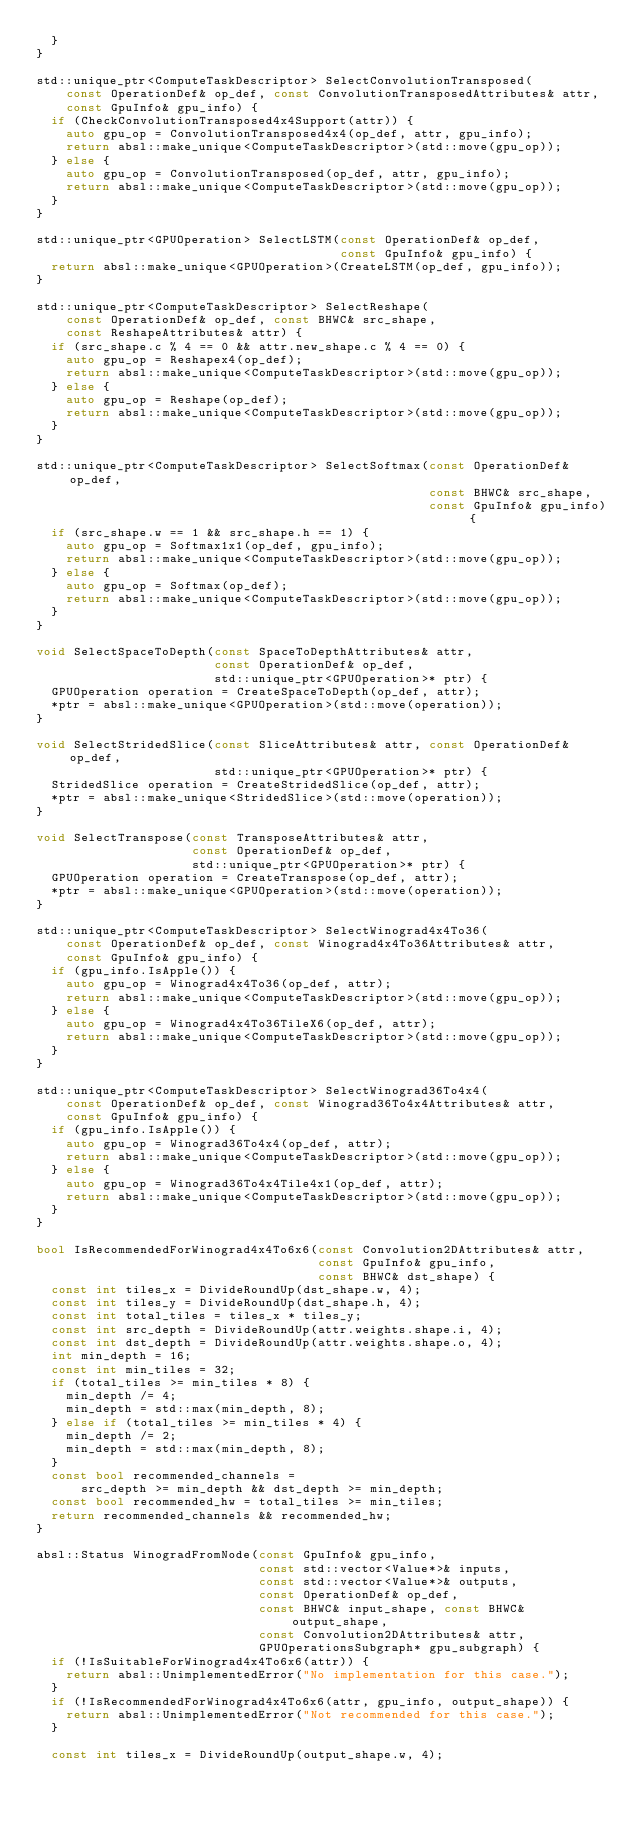<code> <loc_0><loc_0><loc_500><loc_500><_C++_>  }
}

std::unique_ptr<ComputeTaskDescriptor> SelectConvolutionTransposed(
    const OperationDef& op_def, const ConvolutionTransposedAttributes& attr,
    const GpuInfo& gpu_info) {
  if (CheckConvolutionTransposed4x4Support(attr)) {
    auto gpu_op = ConvolutionTransposed4x4(op_def, attr, gpu_info);
    return absl::make_unique<ComputeTaskDescriptor>(std::move(gpu_op));
  } else {
    auto gpu_op = ConvolutionTransposed(op_def, attr, gpu_info);
    return absl::make_unique<ComputeTaskDescriptor>(std::move(gpu_op));
  }
}

std::unique_ptr<GPUOperation> SelectLSTM(const OperationDef& op_def,
                                         const GpuInfo& gpu_info) {
  return absl::make_unique<GPUOperation>(CreateLSTM(op_def, gpu_info));
}

std::unique_ptr<ComputeTaskDescriptor> SelectReshape(
    const OperationDef& op_def, const BHWC& src_shape,
    const ReshapeAttributes& attr) {
  if (src_shape.c % 4 == 0 && attr.new_shape.c % 4 == 0) {
    auto gpu_op = Reshapex4(op_def);
    return absl::make_unique<ComputeTaskDescriptor>(std::move(gpu_op));
  } else {
    auto gpu_op = Reshape(op_def);
    return absl::make_unique<ComputeTaskDescriptor>(std::move(gpu_op));
  }
}

std::unique_ptr<ComputeTaskDescriptor> SelectSoftmax(const OperationDef& op_def,
                                                     const BHWC& src_shape,
                                                     const GpuInfo& gpu_info) {
  if (src_shape.w == 1 && src_shape.h == 1) {
    auto gpu_op = Softmax1x1(op_def, gpu_info);
    return absl::make_unique<ComputeTaskDescriptor>(std::move(gpu_op));
  } else {
    auto gpu_op = Softmax(op_def);
    return absl::make_unique<ComputeTaskDescriptor>(std::move(gpu_op));
  }
}

void SelectSpaceToDepth(const SpaceToDepthAttributes& attr,
                        const OperationDef& op_def,
                        std::unique_ptr<GPUOperation>* ptr) {
  GPUOperation operation = CreateSpaceToDepth(op_def, attr);
  *ptr = absl::make_unique<GPUOperation>(std::move(operation));
}

void SelectStridedSlice(const SliceAttributes& attr, const OperationDef& op_def,
                        std::unique_ptr<GPUOperation>* ptr) {
  StridedSlice operation = CreateStridedSlice(op_def, attr);
  *ptr = absl::make_unique<StridedSlice>(std::move(operation));
}

void SelectTranspose(const TransposeAttributes& attr,
                     const OperationDef& op_def,
                     std::unique_ptr<GPUOperation>* ptr) {
  GPUOperation operation = CreateTranspose(op_def, attr);
  *ptr = absl::make_unique<GPUOperation>(std::move(operation));
}

std::unique_ptr<ComputeTaskDescriptor> SelectWinograd4x4To36(
    const OperationDef& op_def, const Winograd4x4To36Attributes& attr,
    const GpuInfo& gpu_info) {
  if (gpu_info.IsApple()) {
    auto gpu_op = Winograd4x4To36(op_def, attr);
    return absl::make_unique<ComputeTaskDescriptor>(std::move(gpu_op));
  } else {
    auto gpu_op = Winograd4x4To36TileX6(op_def, attr);
    return absl::make_unique<ComputeTaskDescriptor>(std::move(gpu_op));
  }
}

std::unique_ptr<ComputeTaskDescriptor> SelectWinograd36To4x4(
    const OperationDef& op_def, const Winograd36To4x4Attributes& attr,
    const GpuInfo& gpu_info) {
  if (gpu_info.IsApple()) {
    auto gpu_op = Winograd36To4x4(op_def, attr);
    return absl::make_unique<ComputeTaskDescriptor>(std::move(gpu_op));
  } else {
    auto gpu_op = Winograd36To4x4Tile4x1(op_def, attr);
    return absl::make_unique<ComputeTaskDescriptor>(std::move(gpu_op));
  }
}

bool IsRecommendedForWinograd4x4To6x6(const Convolution2DAttributes& attr,
                                      const GpuInfo& gpu_info,
                                      const BHWC& dst_shape) {
  const int tiles_x = DivideRoundUp(dst_shape.w, 4);
  const int tiles_y = DivideRoundUp(dst_shape.h, 4);
  const int total_tiles = tiles_x * tiles_y;
  const int src_depth = DivideRoundUp(attr.weights.shape.i, 4);
  const int dst_depth = DivideRoundUp(attr.weights.shape.o, 4);
  int min_depth = 16;
  const int min_tiles = 32;
  if (total_tiles >= min_tiles * 8) {
    min_depth /= 4;
    min_depth = std::max(min_depth, 8);
  } else if (total_tiles >= min_tiles * 4) {
    min_depth /= 2;
    min_depth = std::max(min_depth, 8);
  }
  const bool recommended_channels =
      src_depth >= min_depth && dst_depth >= min_depth;
  const bool recommended_hw = total_tiles >= min_tiles;
  return recommended_channels && recommended_hw;
}

absl::Status WinogradFromNode(const GpuInfo& gpu_info,
                              const std::vector<Value*>& inputs,
                              const std::vector<Value*>& outputs,
                              const OperationDef& op_def,
                              const BHWC& input_shape, const BHWC& output_shape,
                              const Convolution2DAttributes& attr,
                              GPUOperationsSubgraph* gpu_subgraph) {
  if (!IsSuitableForWinograd4x4To6x6(attr)) {
    return absl::UnimplementedError("No implementation for this case.");
  }
  if (!IsRecommendedForWinograd4x4To6x6(attr, gpu_info, output_shape)) {
    return absl::UnimplementedError("Not recommended for this case.");
  }

  const int tiles_x = DivideRoundUp(output_shape.w, 4);</code> 